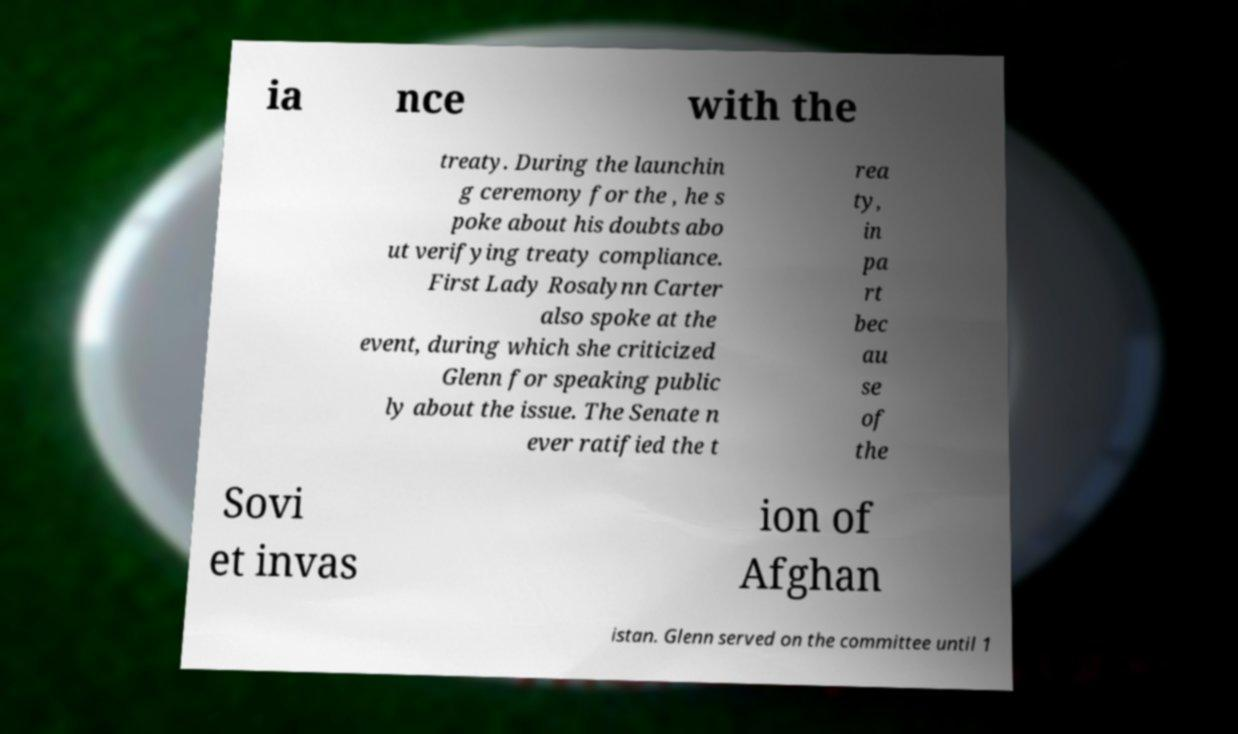There's text embedded in this image that I need extracted. Can you transcribe it verbatim? ia nce with the treaty. During the launchin g ceremony for the , he s poke about his doubts abo ut verifying treaty compliance. First Lady Rosalynn Carter also spoke at the event, during which she criticized Glenn for speaking public ly about the issue. The Senate n ever ratified the t rea ty, in pa rt bec au se of the Sovi et invas ion of Afghan istan. Glenn served on the committee until 1 